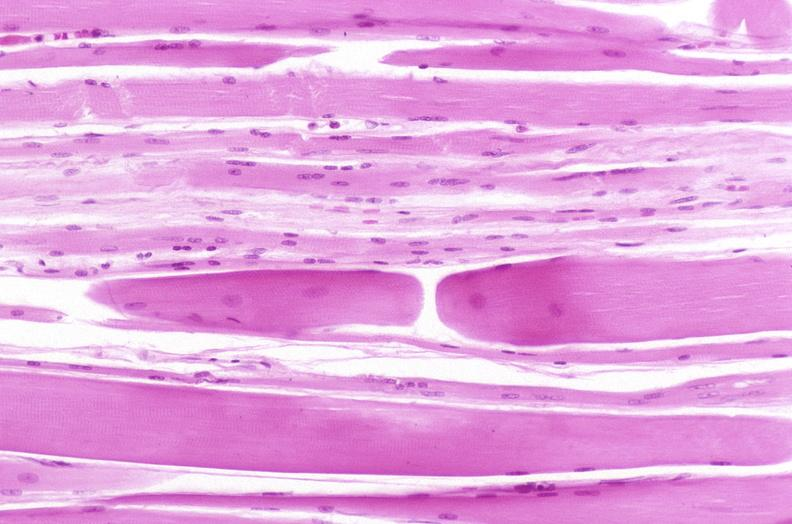does pus in test tube show skeletal muscle, atrophy due to immobilization cast?
Answer the question using a single word or phrase. No 